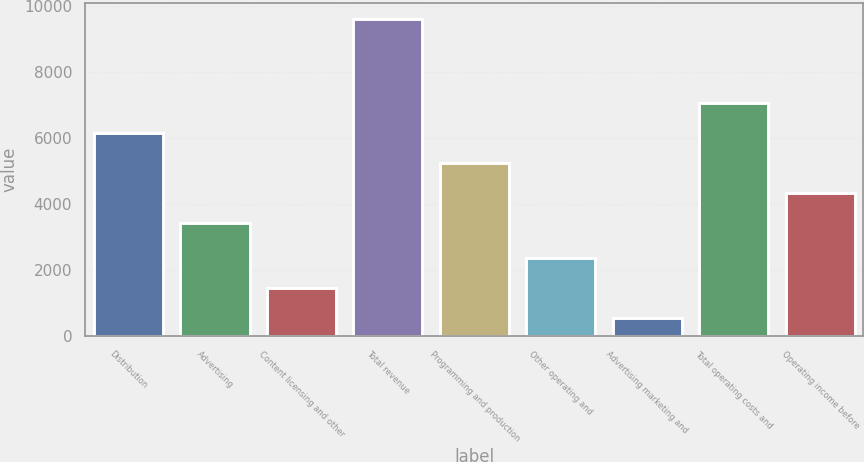Convert chart. <chart><loc_0><loc_0><loc_500><loc_500><bar_chart><fcel>Distribution<fcel>Advertising<fcel>Content licensing and other<fcel>Total revenue<fcel>Programming and production<fcel>Other operating and<fcel>Advertising marketing and<fcel>Total operating costs and<fcel>Operating income before<nl><fcel>6161.4<fcel>3435<fcel>1448.8<fcel>9628<fcel>5252.6<fcel>2357.6<fcel>540<fcel>7070.2<fcel>4343.8<nl></chart> 